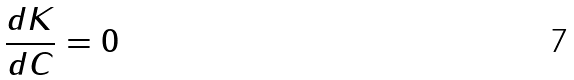Convert formula to latex. <formula><loc_0><loc_0><loc_500><loc_500>\frac { d K } { d C } = 0</formula> 